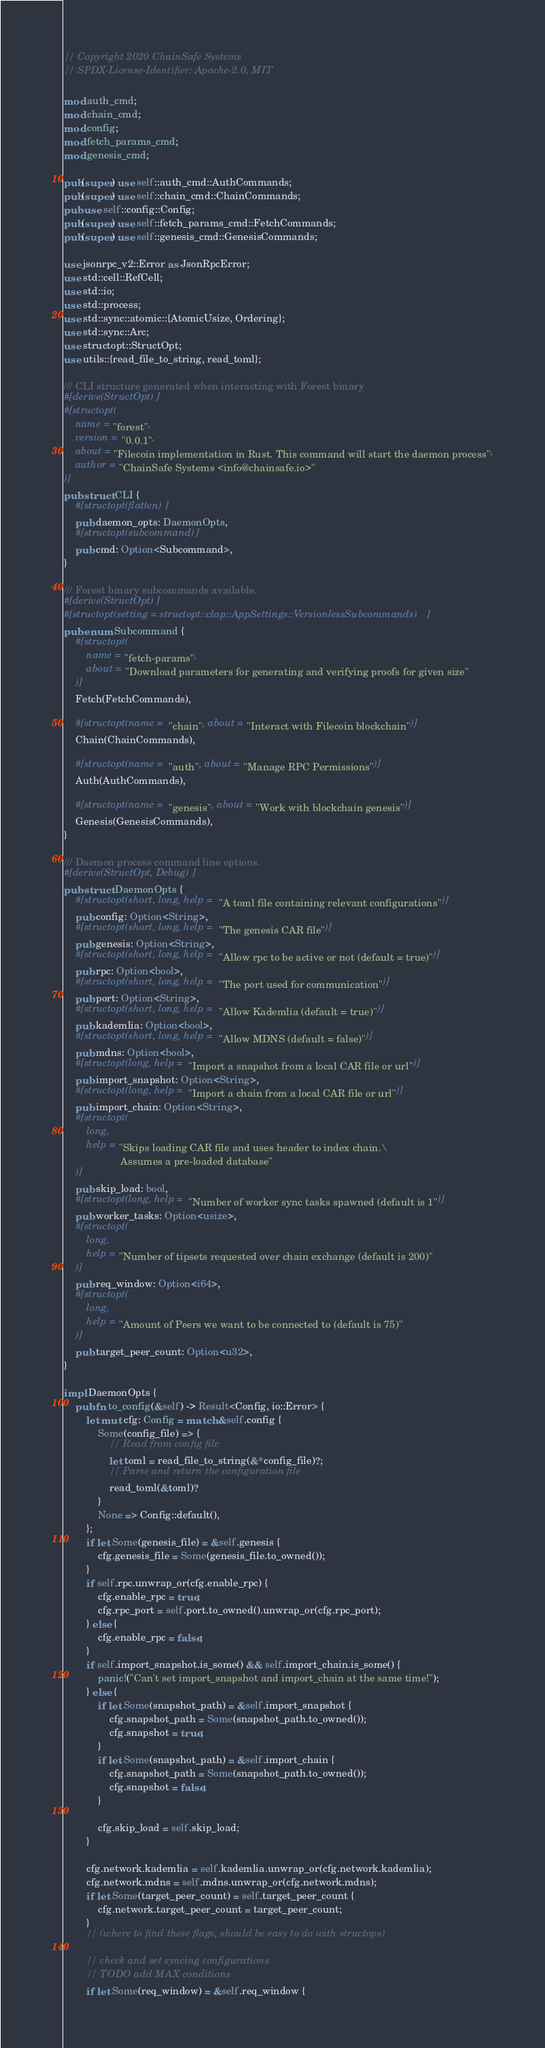Convert code to text. <code><loc_0><loc_0><loc_500><loc_500><_Rust_>// Copyright 2020 ChainSafe Systems
// SPDX-License-Identifier: Apache-2.0, MIT

mod auth_cmd;
mod chain_cmd;
mod config;
mod fetch_params_cmd;
mod genesis_cmd;

pub(super) use self::auth_cmd::AuthCommands;
pub(super) use self::chain_cmd::ChainCommands;
pub use self::config::Config;
pub(super) use self::fetch_params_cmd::FetchCommands;
pub(super) use self::genesis_cmd::GenesisCommands;

use jsonrpc_v2::Error as JsonRpcError;
use std::cell::RefCell;
use std::io;
use std::process;
use std::sync::atomic::{AtomicUsize, Ordering};
use std::sync::Arc;
use structopt::StructOpt;
use utils::{read_file_to_string, read_toml};

/// CLI structure generated when interacting with Forest binary
#[derive(StructOpt)]
#[structopt(
    name = "forest",
    version = "0.0.1",
    about = "Filecoin implementation in Rust. This command will start the daemon process",
    author = "ChainSafe Systems <info@chainsafe.io>"
)]
pub struct CLI {
    #[structopt(flatten)]
    pub daemon_opts: DaemonOpts,
    #[structopt(subcommand)]
    pub cmd: Option<Subcommand>,
}

/// Forest binary subcommands available.
#[derive(StructOpt)]
#[structopt(setting = structopt::clap::AppSettings::VersionlessSubcommands)]
pub enum Subcommand {
    #[structopt(
        name = "fetch-params",
        about = "Download parameters for generating and verifying proofs for given size"
    )]
    Fetch(FetchCommands),

    #[structopt(name = "chain", about = "Interact with Filecoin blockchain")]
    Chain(ChainCommands),

    #[structopt(name = "auth", about = "Manage RPC Permissions")]
    Auth(AuthCommands),

    #[structopt(name = "genesis", about = "Work with blockchain genesis")]
    Genesis(GenesisCommands),
}

/// Daemon process command line options.
#[derive(StructOpt, Debug)]
pub struct DaemonOpts {
    #[structopt(short, long, help = "A toml file containing relevant configurations")]
    pub config: Option<String>,
    #[structopt(short, long, help = "The genesis CAR file")]
    pub genesis: Option<String>,
    #[structopt(short, long, help = "Allow rpc to be active or not (default = true)")]
    pub rpc: Option<bool>,
    #[structopt(short, long, help = "The port used for communication")]
    pub port: Option<String>,
    #[structopt(short, long, help = "Allow Kademlia (default = true)")]
    pub kademlia: Option<bool>,
    #[structopt(short, long, help = "Allow MDNS (default = false)")]
    pub mdns: Option<bool>,
    #[structopt(long, help = "Import a snapshot from a local CAR file or url")]
    pub import_snapshot: Option<String>,
    #[structopt(long, help = "Import a chain from a local CAR file or url")]
    pub import_chain: Option<String>,
    #[structopt(
        long,
        help = "Skips loading CAR file and uses header to index chain.\
                    Assumes a pre-loaded database"
    )]
    pub skip_load: bool,
    #[structopt(long, help = "Number of worker sync tasks spawned (default is 1")]
    pub worker_tasks: Option<usize>,
    #[structopt(
        long,
        help = "Number of tipsets requested over chain exchange (default is 200)"
    )]
    pub req_window: Option<i64>,
    #[structopt(
        long,
        help = "Amount of Peers we want to be connected to (default is 75)"
    )]
    pub target_peer_count: Option<u32>,
}

impl DaemonOpts {
    pub fn to_config(&self) -> Result<Config, io::Error> {
        let mut cfg: Config = match &self.config {
            Some(config_file) => {
                // Read from config file
                let toml = read_file_to_string(&*config_file)?;
                // Parse and return the configuration file
                read_toml(&toml)?
            }
            None => Config::default(),
        };
        if let Some(genesis_file) = &self.genesis {
            cfg.genesis_file = Some(genesis_file.to_owned());
        }
        if self.rpc.unwrap_or(cfg.enable_rpc) {
            cfg.enable_rpc = true;
            cfg.rpc_port = self.port.to_owned().unwrap_or(cfg.rpc_port);
        } else {
            cfg.enable_rpc = false;
        }
        if self.import_snapshot.is_some() && self.import_chain.is_some() {
            panic!("Can't set import_snapshot and import_chain at the same time!");
        } else {
            if let Some(snapshot_path) = &self.import_snapshot {
                cfg.snapshot_path = Some(snapshot_path.to_owned());
                cfg.snapshot = true;
            }
            if let Some(snapshot_path) = &self.import_chain {
                cfg.snapshot_path = Some(snapshot_path.to_owned());
                cfg.snapshot = false;
            }

            cfg.skip_load = self.skip_load;
        }

        cfg.network.kademlia = self.kademlia.unwrap_or(cfg.network.kademlia);
        cfg.network.mdns = self.mdns.unwrap_or(cfg.network.mdns);
        if let Some(target_peer_count) = self.target_peer_count {
            cfg.network.target_peer_count = target_peer_count;
        }
        // (where to find these flags, should be easy to do with structops)

        // check and set syncing configurations
        // TODO add MAX conditions
        if let Some(req_window) = &self.req_window {</code> 